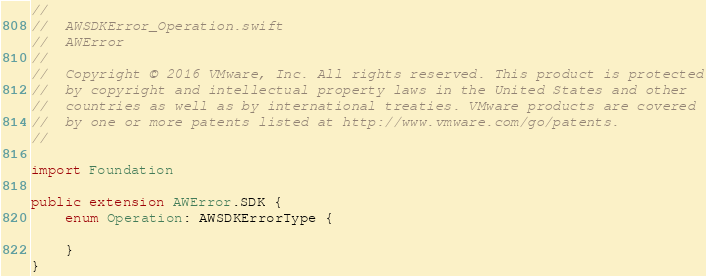<code> <loc_0><loc_0><loc_500><loc_500><_Swift_>//
//  AWSDKError_Operation.swift
//  AWError
//
//  Copyright © 2016 VMware, Inc. All rights reserved. This product is protected
//  by copyright and intellectual property laws in the United States and other
//  countries as well as by international treaties. VMware products are covered
//  by one or more patents listed at http://www.vmware.com/go/patents.
//

import Foundation

public extension AWError.SDK {
    enum Operation: AWSDKErrorType {
        
    }
}</code> 